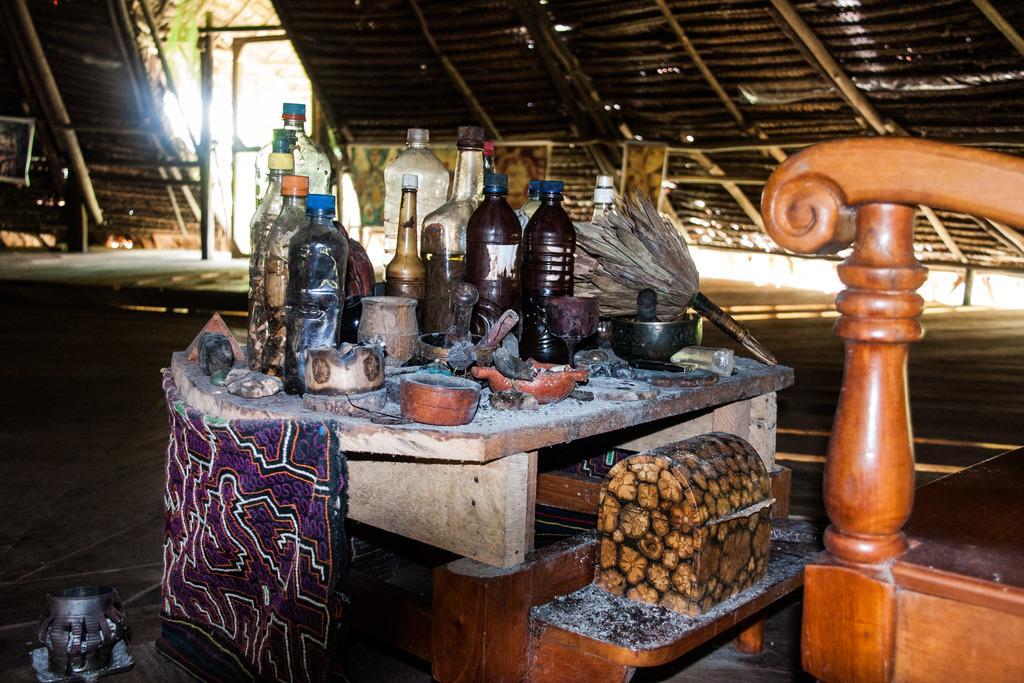Please provide a concise description of this image. there are bottles and few other objects. 